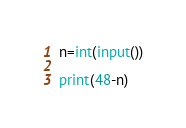<code> <loc_0><loc_0><loc_500><loc_500><_Python_>n=int(input())

print(48-n)</code> 